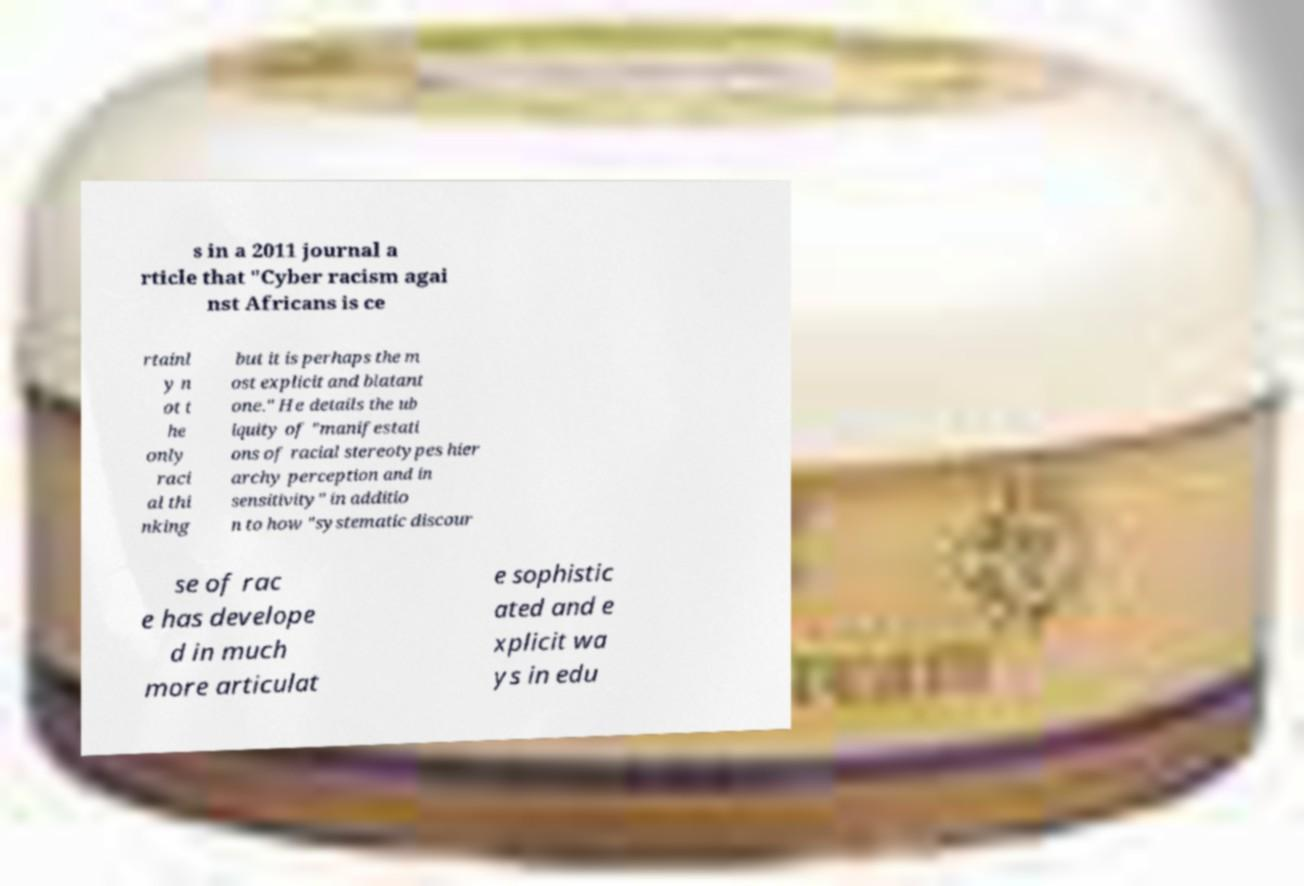For documentation purposes, I need the text within this image transcribed. Could you provide that? s in a 2011 journal a rticle that "Cyber racism agai nst Africans is ce rtainl y n ot t he only raci al thi nking but it is perhaps the m ost explicit and blatant one." He details the ub iquity of "manifestati ons of racial stereotypes hier archy perception and in sensitivity" in additio n to how "systematic discour se of rac e has develope d in much more articulat e sophistic ated and e xplicit wa ys in edu 